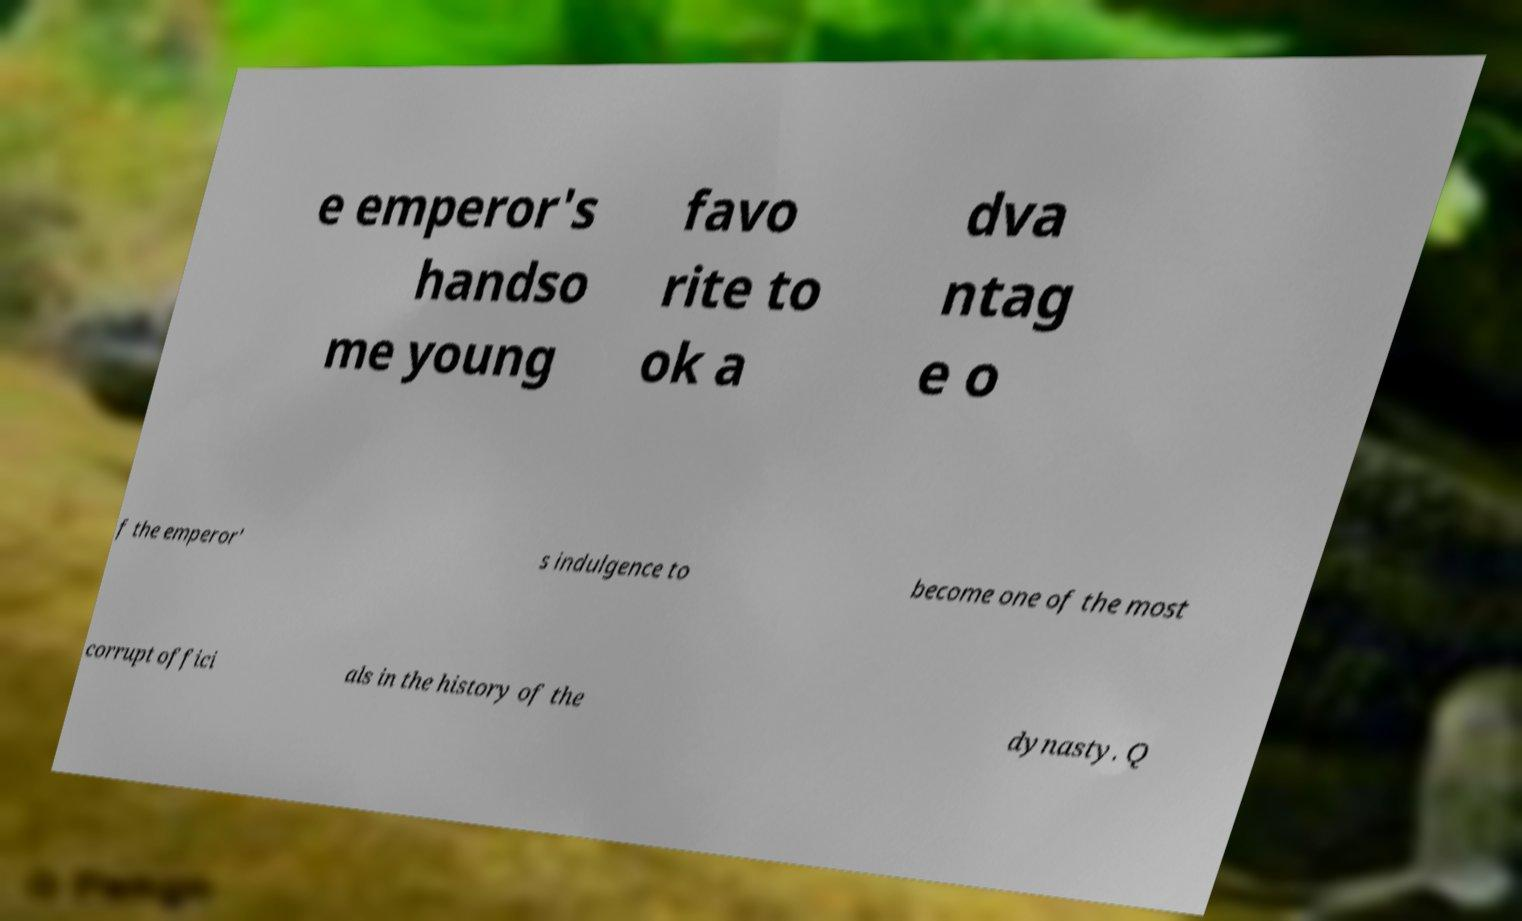What messages or text are displayed in this image? I need them in a readable, typed format. e emperor's handso me young favo rite to ok a dva ntag e o f the emperor' s indulgence to become one of the most corrupt offici als in the history of the dynasty. Q 